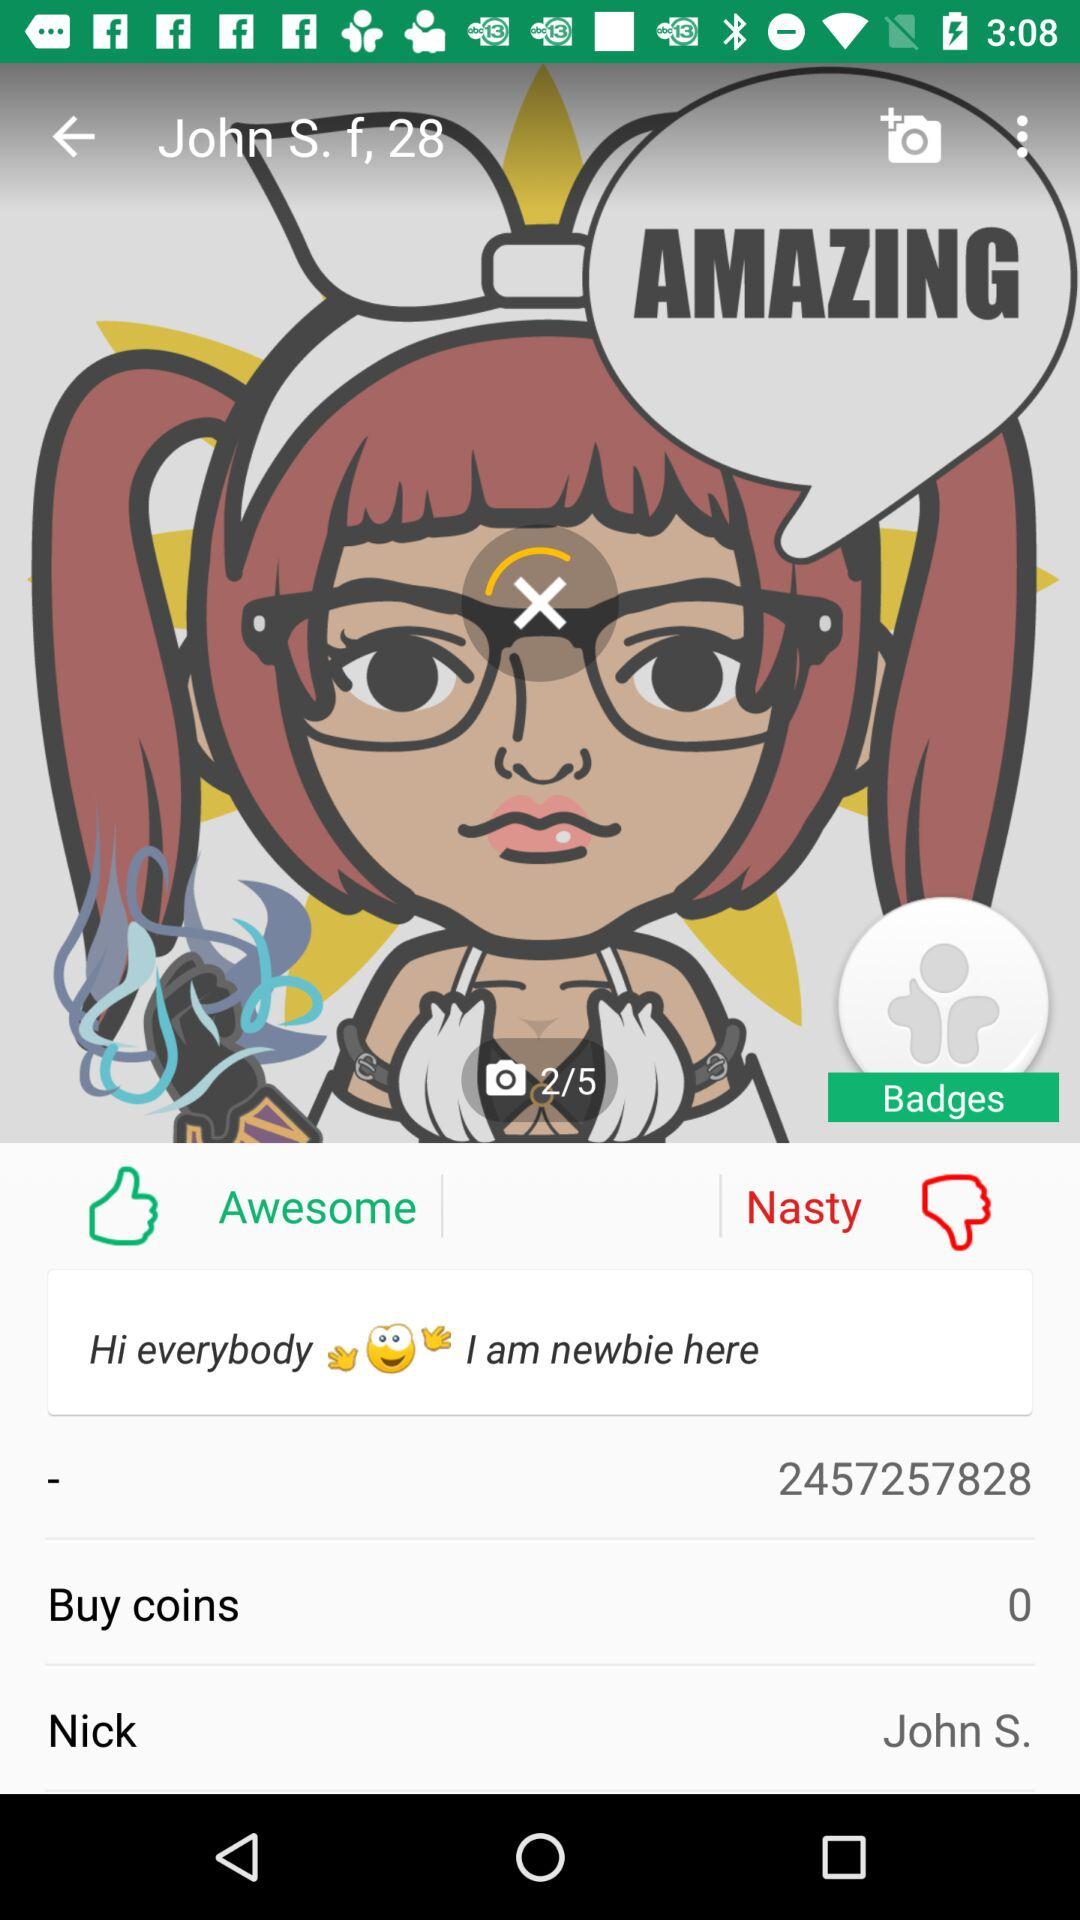How many years old is John? John is 28 years old. 